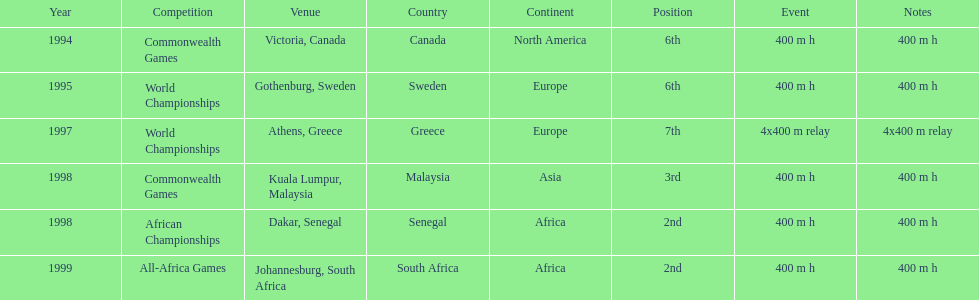What is the number of titles ken harden has one 6. 